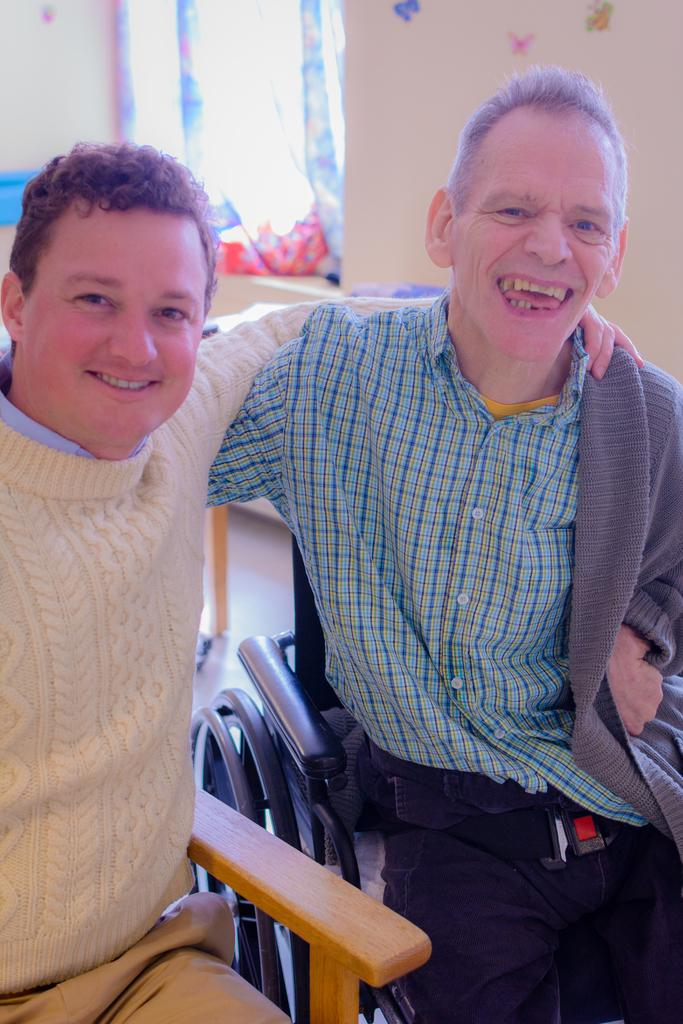How many men are present in the image? There are two men in the image. What are the men doing in the image? The men are sitting on a chair. What is the facial expression of the men in the image? The men are smiling. What type of laborer can be seen working in the image? There is no laborer present in the image; it features two men sitting on a chair. How many eggs are visible on the chair in the image? There are no eggs present in the image. 